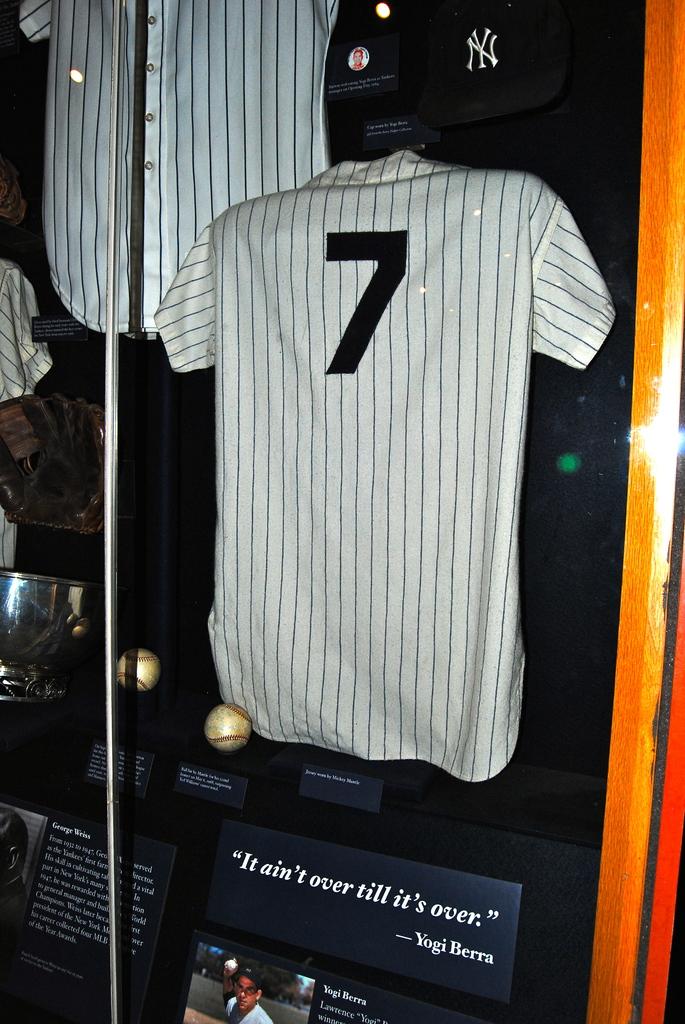What is the quote from the person who wore this jersey?
Ensure brevity in your answer.  It ain't over till it's over. Whose jersey is that?
Offer a terse response. Yogi berra. 